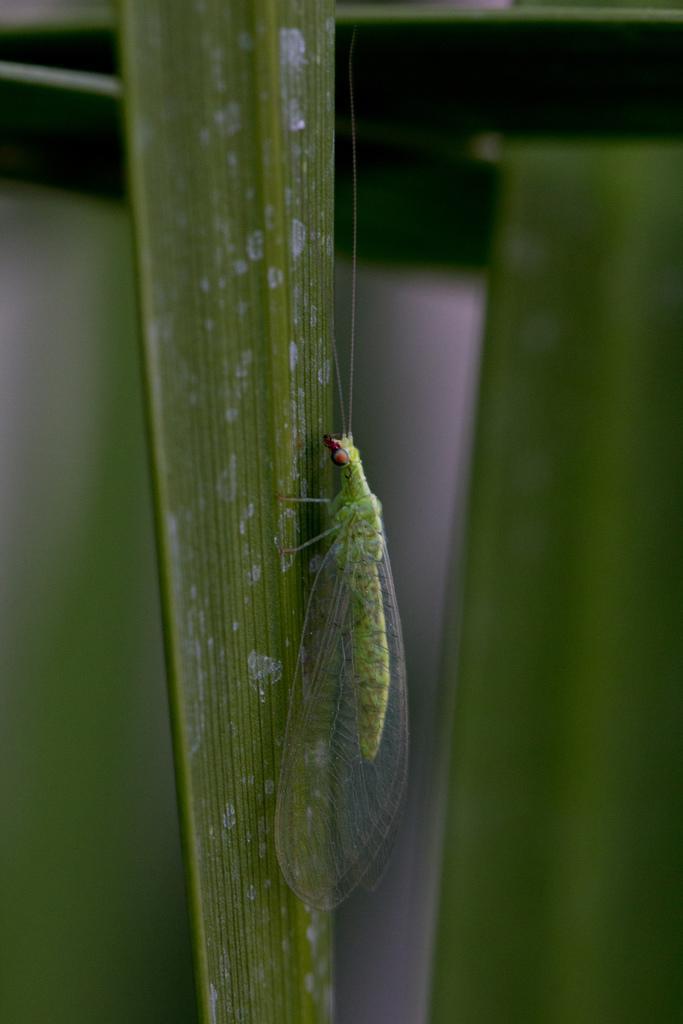How would you summarize this image in a sentence or two? In this picture there is an insect on the leaf. At the back image is blurry. 